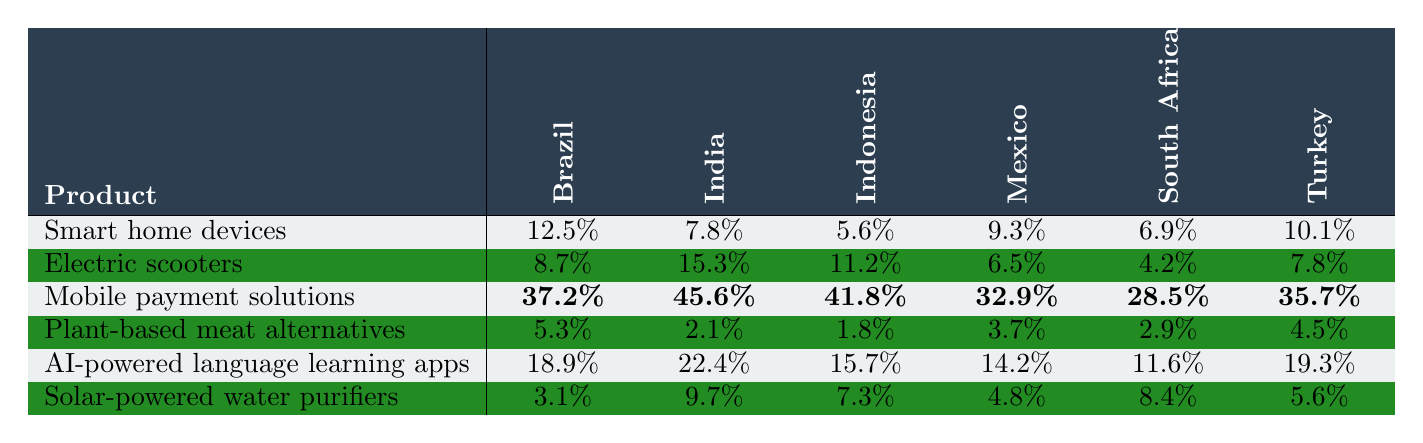What is the penetration rate of mobile payment solutions in India? The table shows that the penetration rate of mobile payment solutions in India is listed directly, which is 45.6%.
Answer: 45.6% Which product has the highest penetration rate in Mexico? By examining the table, the highest penetration rate in Mexico is for mobile payment solutions at 32.9%.
Answer: Mobile payment solutions What is the average penetration rate of smart home devices across all listed countries? To find the average, add all the penetration rates for smart home devices (12.5 + 7.8 + 5.6 + 9.3 + 6.9 + 10.1 = 52.2), and then divide by the number of countries (52.2 / 6 = 8.7).
Answer: 8.7% Is the penetration rate of solar-powered water purifiers higher in Turkey than in Brazil? From the table, Turkey's penetration rate for solar-powered water purifiers is 5.6%, whereas Brazil's is 3.1%, making it true that Turkey's rate is higher.
Answer: Yes Which country has the lowest penetration rate for plant-based meat alternatives? Looking through the table, the lowest penetration rate for plant-based meat alternatives is seen in India, with a rate of 2.1%.
Answer: India What is the difference in penetration rates for electric scooters between India and South Africa? The penetration rate for electric scooters in India is 15.3% and in South Africa is 4.2%. The difference is calculated as 15.3 - 4.2 = 11.1.
Answer: 11.1% Do all countries have a mobile payment penetration rate above 25%? Checking the mobile payment penetration rates in all countries, Brazil (37.2%), India (45.6%), Indonesia (41.8%), Mexico (32.9%), South Africa (28.5%), and Turkey (35.7%) are all above 25%, confirming that this statement is true.
Answer: Yes Which product has the lowest average penetration rate across all six countries? The average penetration rates for each product are: Smart home devices (8.7%), Electric scooters (9.4%), Mobile payment solutions (35.7%), Plant-based meat alternatives (3.5%), AI-powered language learning apps (15.1%), and Solar-powered water purifiers (6.6%). The lowest average is for plant-based meat alternatives at 3.5%.
Answer: Plant-based meat alternatives What is the total penetration rate for solar-powered water purifiers across all countries? Adding the penetration rates for solar-powered water purifiers (3.1 + 9.7 + 7.3 + 4.8 + 8.4 + 5.6 = 39.9), the total is 39.9%.
Answer: 39.9% In which country does AI-powered language learning apps have a penetration rate closest to the median rate across all countries? Calculating the median requires sorting the rates for AI-powered language learning apps: Brazil (18.9%), India (22.4%), Indonesia (15.7%), Mexico (14.2%), South Africa (11.6%), Turkey (19.3%). The median is 18.9%. Comparing, the closest is Turkey at 19.3%.
Answer: Turkey 